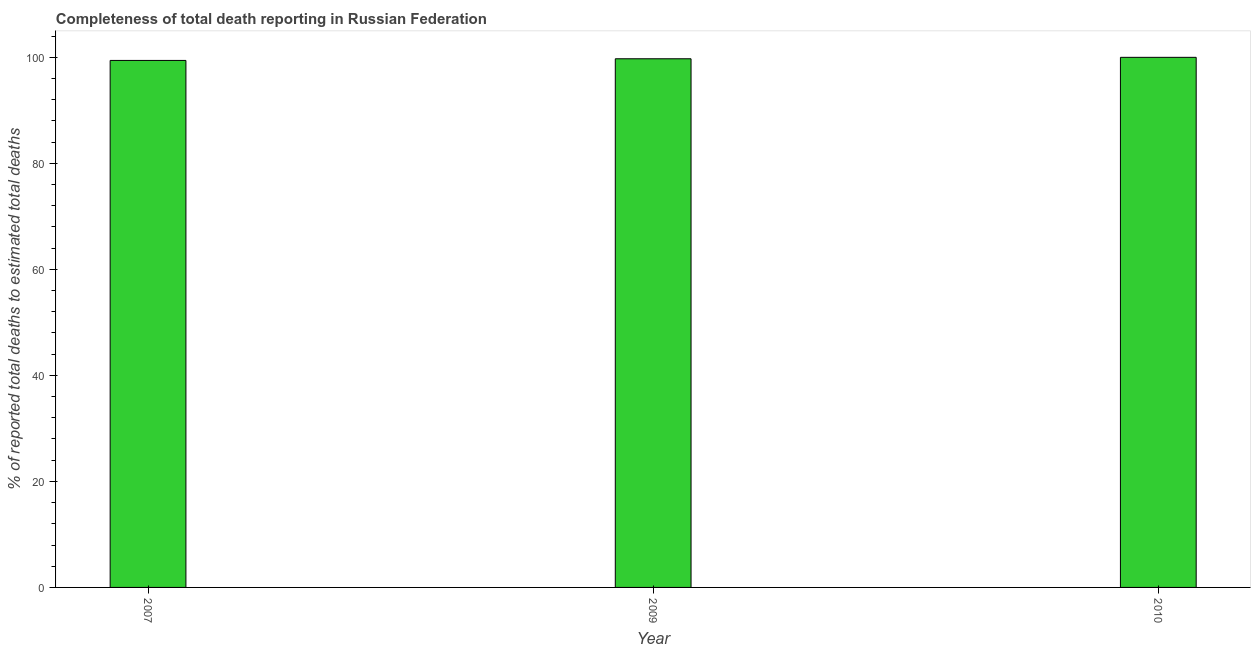What is the title of the graph?
Your response must be concise. Completeness of total death reporting in Russian Federation. What is the label or title of the Y-axis?
Provide a short and direct response. % of reported total deaths to estimated total deaths. What is the completeness of total death reports in 2007?
Keep it short and to the point. 99.41. Across all years, what is the minimum completeness of total death reports?
Provide a succinct answer. 99.41. What is the sum of the completeness of total death reports?
Your answer should be very brief. 299.14. What is the difference between the completeness of total death reports in 2007 and 2009?
Offer a terse response. -0.31. What is the average completeness of total death reports per year?
Provide a short and direct response. 99.71. What is the median completeness of total death reports?
Your answer should be compact. 99.73. In how many years, is the completeness of total death reports greater than 64 %?
Provide a succinct answer. 3. What is the ratio of the completeness of total death reports in 2007 to that in 2010?
Your answer should be compact. 0.99. What is the difference between the highest and the second highest completeness of total death reports?
Offer a terse response. 0.27. What is the difference between the highest and the lowest completeness of total death reports?
Keep it short and to the point. 0.59. How many bars are there?
Your answer should be compact. 3. Are all the bars in the graph horizontal?
Keep it short and to the point. No. What is the % of reported total deaths to estimated total deaths of 2007?
Provide a short and direct response. 99.41. What is the % of reported total deaths to estimated total deaths in 2009?
Give a very brief answer. 99.73. What is the difference between the % of reported total deaths to estimated total deaths in 2007 and 2009?
Provide a succinct answer. -0.31. What is the difference between the % of reported total deaths to estimated total deaths in 2007 and 2010?
Keep it short and to the point. -0.59. What is the difference between the % of reported total deaths to estimated total deaths in 2009 and 2010?
Offer a very short reply. -0.27. What is the ratio of the % of reported total deaths to estimated total deaths in 2007 to that in 2010?
Keep it short and to the point. 0.99. What is the ratio of the % of reported total deaths to estimated total deaths in 2009 to that in 2010?
Offer a very short reply. 1. 